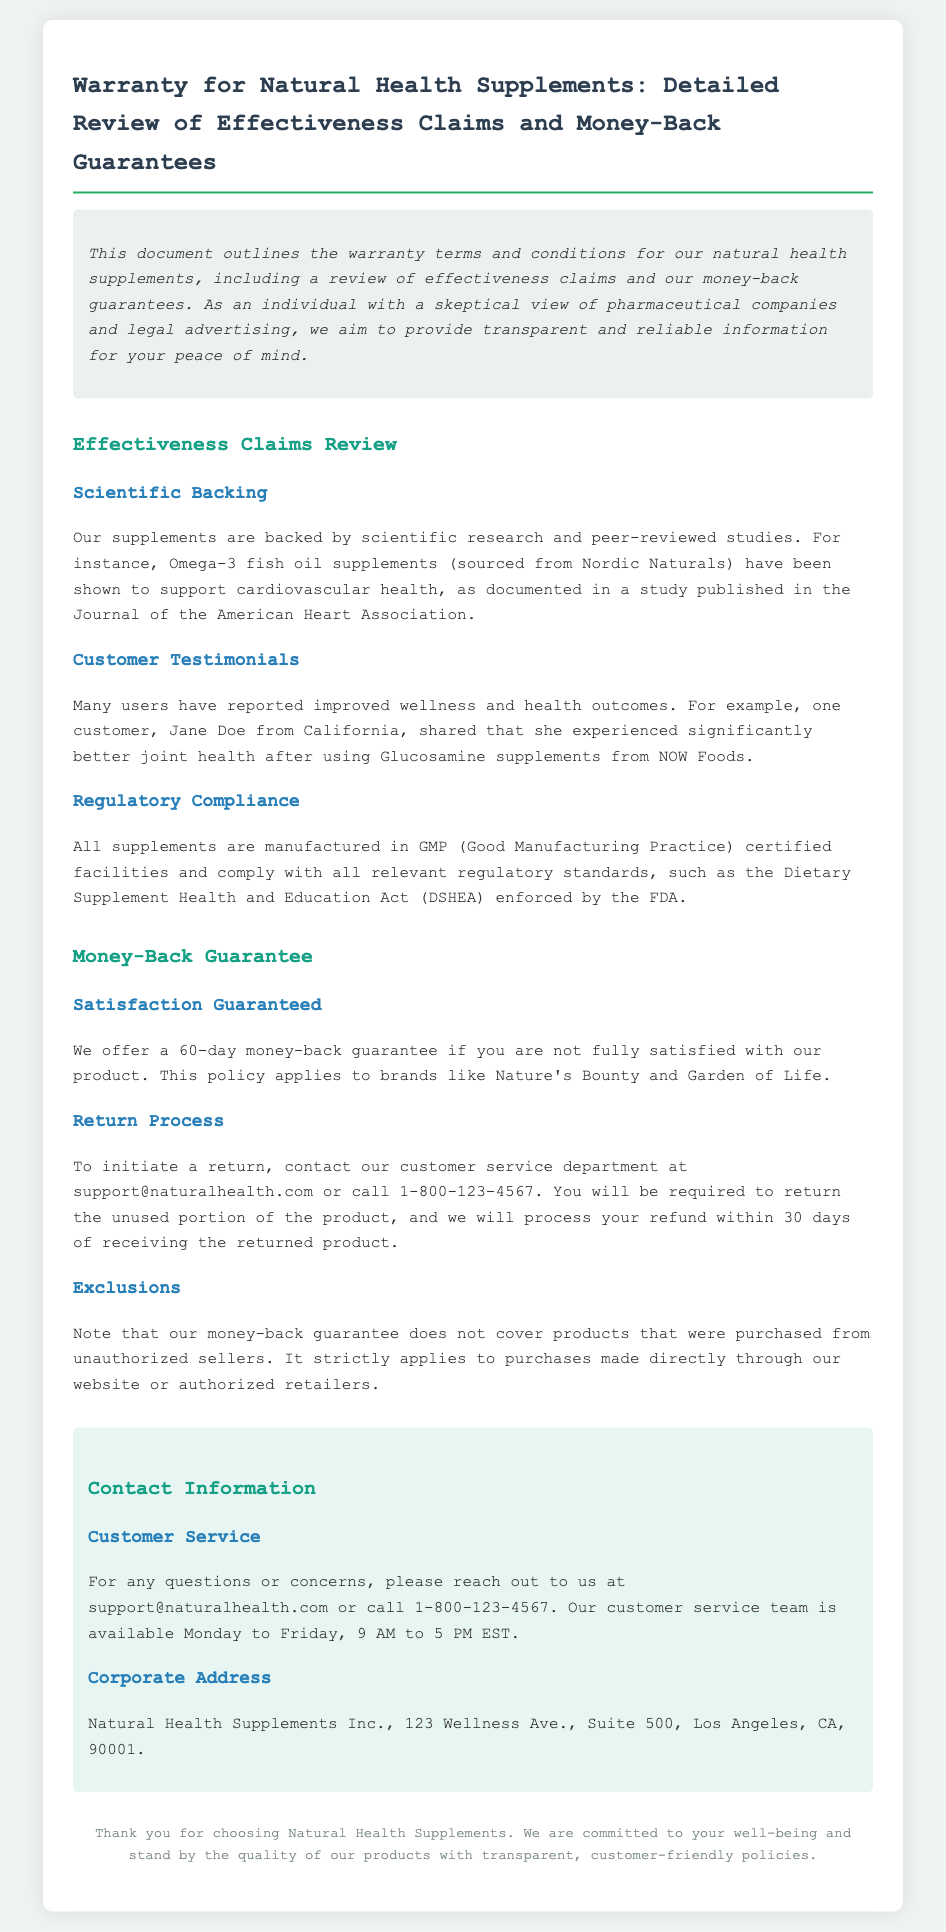What is the money-back guarantee period? The document states that there is a 60-day money-back guarantee if you are not fully satisfied with the product.
Answer: 60 days What types of supplements are mentioned in the effectiveness claims? Omega-3 fish oil and Glucosamine supplements are specifically mentioned as part of the effectiveness claims review.
Answer: Omega-3 fish oil and Glucosamine Who reported improved wellness with Glucosamine? The document provides a specific example of a customer named Jane Doe from California who experienced better joint health using Glucosamine.
Answer: Jane Doe What certification do the facilities have? It is mentioned that all supplements are manufactured in GMP (Good Manufacturing Practice) certified facilities.
Answer: GMP certified What should be done to initiate a return? According to the document, one must contact customer service to initiate a return for the money-back guarantee.
Answer: Contact customer service Can products purchased from unauthorized sellers be returned? The document explicitly states that the money-back guarantee does not cover products purchased from unauthorized sellers.
Answer: No What is the corporate address of Natural Health Supplements Inc.? The corporate address provided in the document is 123 Wellness Ave., Suite 500, Los Angeles, CA, 90001.
Answer: 123 Wellness Ave., Suite 500, Los Angeles, CA, 90001 What type of studies back the effectiveness claims? The effectiveness claims are backed by scientific research and peer-reviewed studies.
Answer: Scientific research and peer-reviewed studies How long after receiving a returned product is a refund processed? The document states that refunds will be processed within 30 days of receiving the returned product.
Answer: 30 days 